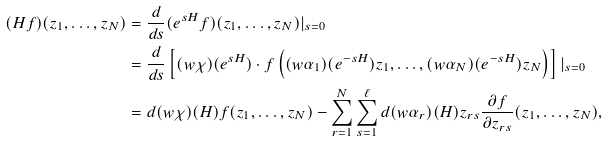Convert formula to latex. <formula><loc_0><loc_0><loc_500><loc_500>( H f ) ( z _ { 1 } , \dots , z _ { N } ) & = \frac { d } { d s } ( e ^ { s H } f ) ( z _ { 1 } , \dots , z _ { N } ) | _ { s = 0 } \\ & = \frac { d } { d s } \left [ ( w \chi ) ( e ^ { s H } ) \cdot f \left ( ( w \alpha _ { 1 } ) ( e ^ { - s H } ) z _ { 1 } , \dots , ( w \alpha _ { N } ) ( e ^ { - s H } ) z _ { N } \right ) \right ] | _ { s = 0 } \\ & = d ( w \chi ) ( H ) f ( z _ { 1 } , \dots , z _ { N } ) - \sum _ { r = 1 } ^ { N } \sum _ { s = 1 } ^ { \ell } d ( w \alpha _ { r } ) ( H ) z _ { r s } \frac { \partial f } { \partial z _ { r s } } ( z _ { 1 } , \dots , z _ { N } ) ,</formula> 